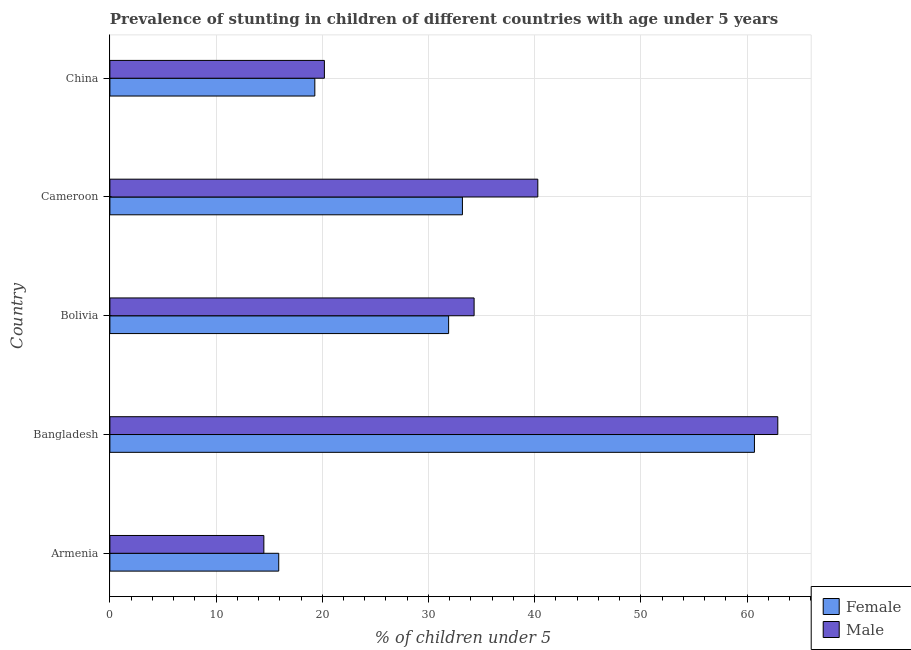How many groups of bars are there?
Ensure brevity in your answer.  5. How many bars are there on the 1st tick from the top?
Your answer should be compact. 2. How many bars are there on the 1st tick from the bottom?
Ensure brevity in your answer.  2. What is the label of the 2nd group of bars from the top?
Make the answer very short. Cameroon. What is the percentage of stunted female children in Bangladesh?
Your answer should be very brief. 60.7. Across all countries, what is the maximum percentage of stunted female children?
Provide a short and direct response. 60.7. Across all countries, what is the minimum percentage of stunted female children?
Keep it short and to the point. 15.9. In which country was the percentage of stunted female children maximum?
Make the answer very short. Bangladesh. In which country was the percentage of stunted male children minimum?
Provide a short and direct response. Armenia. What is the total percentage of stunted male children in the graph?
Keep it short and to the point. 172.2. What is the difference between the percentage of stunted female children in Bangladesh and that in Bolivia?
Offer a terse response. 28.8. What is the difference between the percentage of stunted male children in Bangladesh and the percentage of stunted female children in China?
Your answer should be very brief. 43.6. What is the average percentage of stunted male children per country?
Offer a very short reply. 34.44. What is the ratio of the percentage of stunted male children in Bangladesh to that in Bolivia?
Provide a succinct answer. 1.83. Is the difference between the percentage of stunted female children in Armenia and China greater than the difference between the percentage of stunted male children in Armenia and China?
Offer a terse response. Yes. What is the difference between the highest and the second highest percentage of stunted male children?
Offer a very short reply. 22.6. What is the difference between the highest and the lowest percentage of stunted female children?
Keep it short and to the point. 44.8. What does the 1st bar from the top in Armenia represents?
Your answer should be compact. Male. What does the 2nd bar from the bottom in Cameroon represents?
Keep it short and to the point. Male. How many bars are there?
Offer a very short reply. 10. Are all the bars in the graph horizontal?
Your answer should be very brief. Yes. Are the values on the major ticks of X-axis written in scientific E-notation?
Your answer should be compact. No. Does the graph contain grids?
Ensure brevity in your answer.  Yes. How are the legend labels stacked?
Your answer should be compact. Vertical. What is the title of the graph?
Give a very brief answer. Prevalence of stunting in children of different countries with age under 5 years. Does "Automatic Teller Machines" appear as one of the legend labels in the graph?
Keep it short and to the point. No. What is the label or title of the X-axis?
Provide a short and direct response.  % of children under 5. What is the label or title of the Y-axis?
Give a very brief answer. Country. What is the  % of children under 5 of Female in Armenia?
Make the answer very short. 15.9. What is the  % of children under 5 in Male in Armenia?
Make the answer very short. 14.5. What is the  % of children under 5 in Female in Bangladesh?
Keep it short and to the point. 60.7. What is the  % of children under 5 of Male in Bangladesh?
Offer a very short reply. 62.9. What is the  % of children under 5 in Female in Bolivia?
Provide a succinct answer. 31.9. What is the  % of children under 5 in Male in Bolivia?
Provide a succinct answer. 34.3. What is the  % of children under 5 in Female in Cameroon?
Your answer should be very brief. 33.2. What is the  % of children under 5 in Male in Cameroon?
Provide a short and direct response. 40.3. What is the  % of children under 5 of Female in China?
Your answer should be compact. 19.3. What is the  % of children under 5 in Male in China?
Provide a succinct answer. 20.2. Across all countries, what is the maximum  % of children under 5 in Female?
Make the answer very short. 60.7. Across all countries, what is the maximum  % of children under 5 in Male?
Provide a succinct answer. 62.9. Across all countries, what is the minimum  % of children under 5 in Female?
Your response must be concise. 15.9. Across all countries, what is the minimum  % of children under 5 of Male?
Give a very brief answer. 14.5. What is the total  % of children under 5 in Female in the graph?
Keep it short and to the point. 161. What is the total  % of children under 5 of Male in the graph?
Your answer should be compact. 172.2. What is the difference between the  % of children under 5 in Female in Armenia and that in Bangladesh?
Your answer should be compact. -44.8. What is the difference between the  % of children under 5 of Male in Armenia and that in Bangladesh?
Your answer should be compact. -48.4. What is the difference between the  % of children under 5 of Male in Armenia and that in Bolivia?
Keep it short and to the point. -19.8. What is the difference between the  % of children under 5 in Female in Armenia and that in Cameroon?
Make the answer very short. -17.3. What is the difference between the  % of children under 5 of Male in Armenia and that in Cameroon?
Give a very brief answer. -25.8. What is the difference between the  % of children under 5 in Female in Armenia and that in China?
Offer a very short reply. -3.4. What is the difference between the  % of children under 5 of Male in Armenia and that in China?
Provide a succinct answer. -5.7. What is the difference between the  % of children under 5 in Female in Bangladesh and that in Bolivia?
Your response must be concise. 28.8. What is the difference between the  % of children under 5 of Male in Bangladesh and that in Bolivia?
Give a very brief answer. 28.6. What is the difference between the  % of children under 5 in Female in Bangladesh and that in Cameroon?
Provide a short and direct response. 27.5. What is the difference between the  % of children under 5 of Male in Bangladesh and that in Cameroon?
Give a very brief answer. 22.6. What is the difference between the  % of children under 5 in Female in Bangladesh and that in China?
Offer a very short reply. 41.4. What is the difference between the  % of children under 5 of Male in Bangladesh and that in China?
Keep it short and to the point. 42.7. What is the difference between the  % of children under 5 in Male in Bolivia and that in Cameroon?
Your answer should be compact. -6. What is the difference between the  % of children under 5 of Female in Cameroon and that in China?
Your answer should be very brief. 13.9. What is the difference between the  % of children under 5 in Male in Cameroon and that in China?
Offer a terse response. 20.1. What is the difference between the  % of children under 5 of Female in Armenia and the  % of children under 5 of Male in Bangladesh?
Provide a succinct answer. -47. What is the difference between the  % of children under 5 of Female in Armenia and the  % of children under 5 of Male in Bolivia?
Offer a very short reply. -18.4. What is the difference between the  % of children under 5 of Female in Armenia and the  % of children under 5 of Male in Cameroon?
Offer a very short reply. -24.4. What is the difference between the  % of children under 5 of Female in Bangladesh and the  % of children under 5 of Male in Bolivia?
Your response must be concise. 26.4. What is the difference between the  % of children under 5 of Female in Bangladesh and the  % of children under 5 of Male in Cameroon?
Ensure brevity in your answer.  20.4. What is the difference between the  % of children under 5 of Female in Bangladesh and the  % of children under 5 of Male in China?
Your answer should be compact. 40.5. What is the difference between the  % of children under 5 in Female in Bolivia and the  % of children under 5 in Male in Cameroon?
Your response must be concise. -8.4. What is the difference between the  % of children under 5 of Female in Bolivia and the  % of children under 5 of Male in China?
Give a very brief answer. 11.7. What is the difference between the  % of children under 5 in Female in Cameroon and the  % of children under 5 in Male in China?
Offer a very short reply. 13. What is the average  % of children under 5 of Female per country?
Keep it short and to the point. 32.2. What is the average  % of children under 5 of Male per country?
Ensure brevity in your answer.  34.44. What is the difference between the  % of children under 5 in Female and  % of children under 5 in Male in Armenia?
Your response must be concise. 1.4. What is the difference between the  % of children under 5 in Female and  % of children under 5 in Male in Bangladesh?
Provide a short and direct response. -2.2. What is the difference between the  % of children under 5 of Female and  % of children under 5 of Male in Bolivia?
Offer a very short reply. -2.4. What is the ratio of the  % of children under 5 of Female in Armenia to that in Bangladesh?
Provide a succinct answer. 0.26. What is the ratio of the  % of children under 5 in Male in Armenia to that in Bangladesh?
Keep it short and to the point. 0.23. What is the ratio of the  % of children under 5 of Female in Armenia to that in Bolivia?
Your response must be concise. 0.5. What is the ratio of the  % of children under 5 in Male in Armenia to that in Bolivia?
Provide a short and direct response. 0.42. What is the ratio of the  % of children under 5 in Female in Armenia to that in Cameroon?
Offer a terse response. 0.48. What is the ratio of the  % of children under 5 in Male in Armenia to that in Cameroon?
Keep it short and to the point. 0.36. What is the ratio of the  % of children under 5 of Female in Armenia to that in China?
Make the answer very short. 0.82. What is the ratio of the  % of children under 5 of Male in Armenia to that in China?
Give a very brief answer. 0.72. What is the ratio of the  % of children under 5 of Female in Bangladesh to that in Bolivia?
Your response must be concise. 1.9. What is the ratio of the  % of children under 5 in Male in Bangladesh to that in Bolivia?
Offer a terse response. 1.83. What is the ratio of the  % of children under 5 in Female in Bangladesh to that in Cameroon?
Provide a succinct answer. 1.83. What is the ratio of the  % of children under 5 of Male in Bangladesh to that in Cameroon?
Give a very brief answer. 1.56. What is the ratio of the  % of children under 5 of Female in Bangladesh to that in China?
Your response must be concise. 3.15. What is the ratio of the  % of children under 5 in Male in Bangladesh to that in China?
Provide a short and direct response. 3.11. What is the ratio of the  % of children under 5 in Female in Bolivia to that in Cameroon?
Your answer should be compact. 0.96. What is the ratio of the  % of children under 5 of Male in Bolivia to that in Cameroon?
Provide a short and direct response. 0.85. What is the ratio of the  % of children under 5 of Female in Bolivia to that in China?
Offer a very short reply. 1.65. What is the ratio of the  % of children under 5 in Male in Bolivia to that in China?
Your answer should be very brief. 1.7. What is the ratio of the  % of children under 5 of Female in Cameroon to that in China?
Make the answer very short. 1.72. What is the ratio of the  % of children under 5 of Male in Cameroon to that in China?
Your answer should be compact. 2. What is the difference between the highest and the second highest  % of children under 5 in Female?
Offer a terse response. 27.5. What is the difference between the highest and the second highest  % of children under 5 of Male?
Your response must be concise. 22.6. What is the difference between the highest and the lowest  % of children under 5 in Female?
Provide a succinct answer. 44.8. What is the difference between the highest and the lowest  % of children under 5 of Male?
Provide a short and direct response. 48.4. 